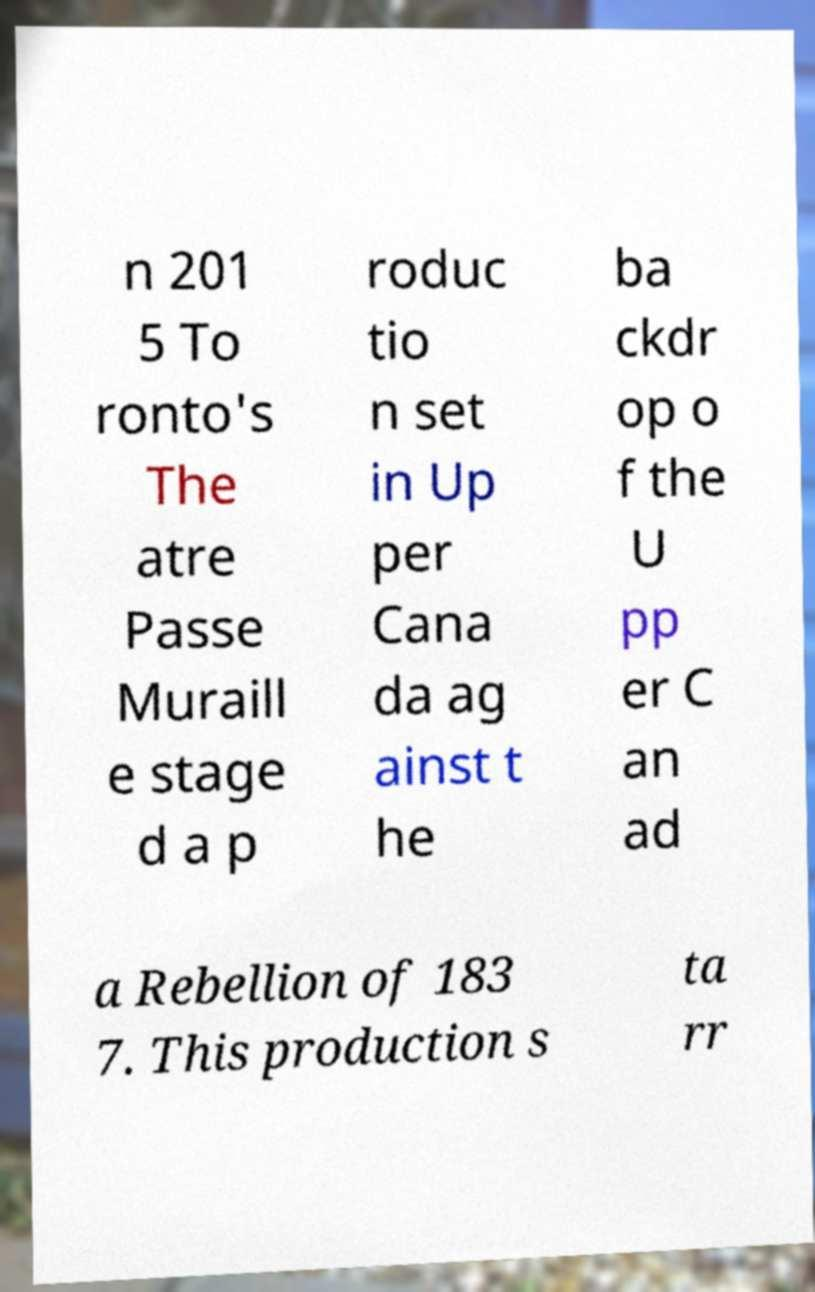Please read and relay the text visible in this image. What does it say? n 201 5 To ronto's The atre Passe Muraill e stage d a p roduc tio n set in Up per Cana da ag ainst t he ba ckdr op o f the U pp er C an ad a Rebellion of 183 7. This production s ta rr 